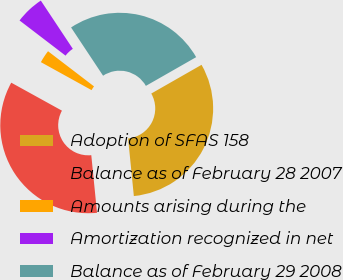Convert chart to OTSL. <chart><loc_0><loc_0><loc_500><loc_500><pie_chart><fcel>Adoption of SFAS 158<fcel>Balance as of February 28 2007<fcel>Amounts arising during the<fcel>Amortization recognized in net<fcel>Balance as of February 29 2008<nl><fcel>31.68%<fcel>34.61%<fcel>2.36%<fcel>5.29%<fcel>26.06%<nl></chart> 